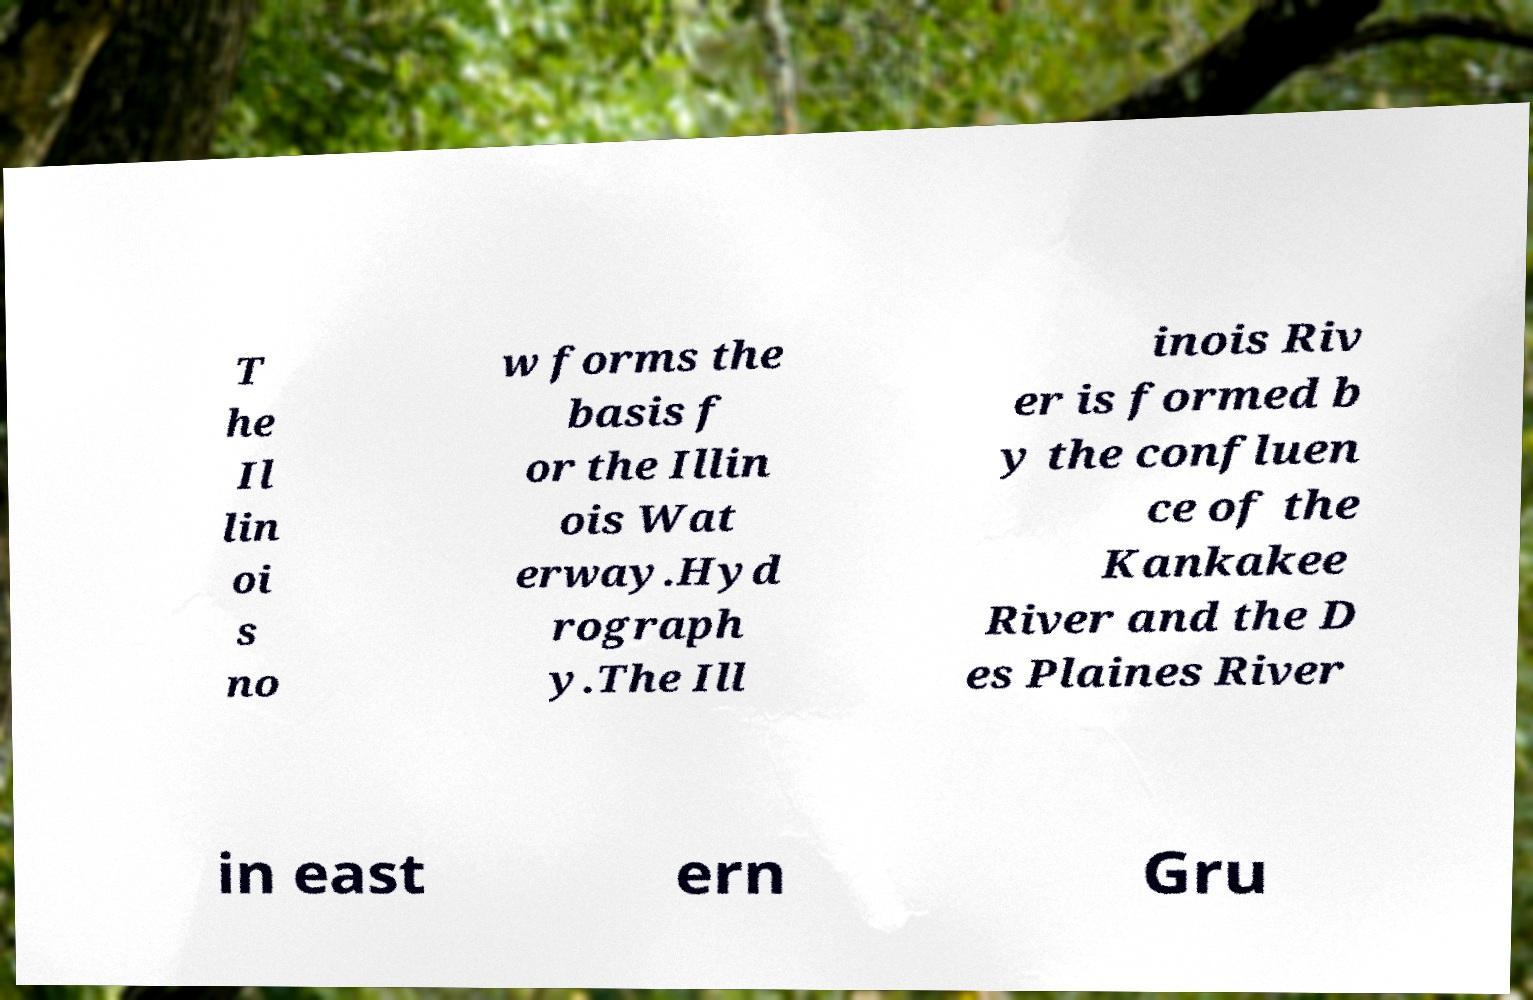Could you extract and type out the text from this image? T he Il lin oi s no w forms the basis f or the Illin ois Wat erway.Hyd rograph y.The Ill inois Riv er is formed b y the confluen ce of the Kankakee River and the D es Plaines River in east ern Gru 